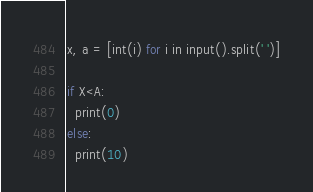Convert code to text. <code><loc_0><loc_0><loc_500><loc_500><_Python_>x, a = [int(i) for i in input().split(' ')]

if X<A:
  print(0)
else:
  print(10)</code> 